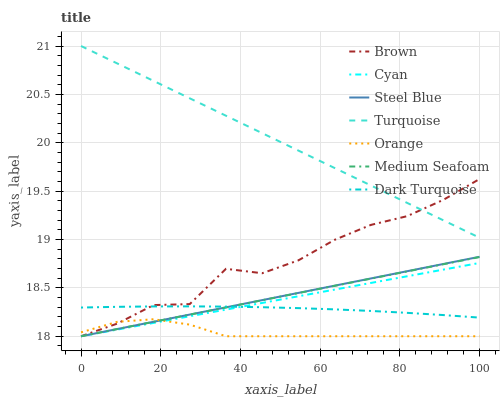Does Orange have the minimum area under the curve?
Answer yes or no. Yes. Does Turquoise have the maximum area under the curve?
Answer yes or no. Yes. Does Dark Turquoise have the minimum area under the curve?
Answer yes or no. No. Does Dark Turquoise have the maximum area under the curve?
Answer yes or no. No. Is Medium Seafoam the smoothest?
Answer yes or no. Yes. Is Brown the roughest?
Answer yes or no. Yes. Is Turquoise the smoothest?
Answer yes or no. No. Is Turquoise the roughest?
Answer yes or no. No. Does Brown have the lowest value?
Answer yes or no. Yes. Does Dark Turquoise have the lowest value?
Answer yes or no. No. Does Turquoise have the highest value?
Answer yes or no. Yes. Does Dark Turquoise have the highest value?
Answer yes or no. No. Is Orange less than Dark Turquoise?
Answer yes or no. Yes. Is Turquoise greater than Medium Seafoam?
Answer yes or no. Yes. Does Steel Blue intersect Medium Seafoam?
Answer yes or no. Yes. Is Steel Blue less than Medium Seafoam?
Answer yes or no. No. Is Steel Blue greater than Medium Seafoam?
Answer yes or no. No. Does Orange intersect Dark Turquoise?
Answer yes or no. No. 